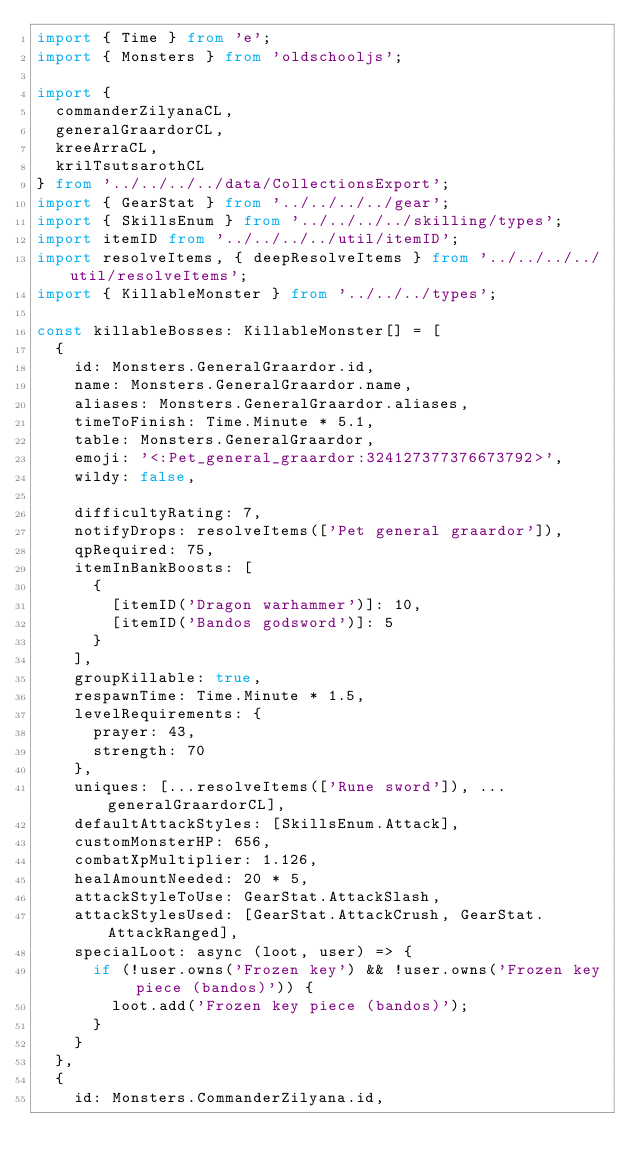<code> <loc_0><loc_0><loc_500><loc_500><_TypeScript_>import { Time } from 'e';
import { Monsters } from 'oldschooljs';

import {
	commanderZilyanaCL,
	generalGraardorCL,
	kreeArraCL,
	krilTsutsarothCL
} from '../../../../data/CollectionsExport';
import { GearStat } from '../../../../gear';
import { SkillsEnum } from '../../../../skilling/types';
import itemID from '../../../../util/itemID';
import resolveItems, { deepResolveItems } from '../../../../util/resolveItems';
import { KillableMonster } from '../../../types';

const killableBosses: KillableMonster[] = [
	{
		id: Monsters.GeneralGraardor.id,
		name: Monsters.GeneralGraardor.name,
		aliases: Monsters.GeneralGraardor.aliases,
		timeToFinish: Time.Minute * 5.1,
		table: Monsters.GeneralGraardor,
		emoji: '<:Pet_general_graardor:324127377376673792>',
		wildy: false,

		difficultyRating: 7,
		notifyDrops: resolveItems(['Pet general graardor']),
		qpRequired: 75,
		itemInBankBoosts: [
			{
				[itemID('Dragon warhammer')]: 10,
				[itemID('Bandos godsword')]: 5
			}
		],
		groupKillable: true,
		respawnTime: Time.Minute * 1.5,
		levelRequirements: {
			prayer: 43,
			strength: 70
		},
		uniques: [...resolveItems(['Rune sword']), ...generalGraardorCL],
		defaultAttackStyles: [SkillsEnum.Attack],
		customMonsterHP: 656,
		combatXpMultiplier: 1.126,
		healAmountNeeded: 20 * 5,
		attackStyleToUse: GearStat.AttackSlash,
		attackStylesUsed: [GearStat.AttackCrush, GearStat.AttackRanged],
		specialLoot: async (loot, user) => {
			if (!user.owns('Frozen key') && !user.owns('Frozen key piece (bandos)')) {
				loot.add('Frozen key piece (bandos)');
			}
		}
	},
	{
		id: Monsters.CommanderZilyana.id,</code> 